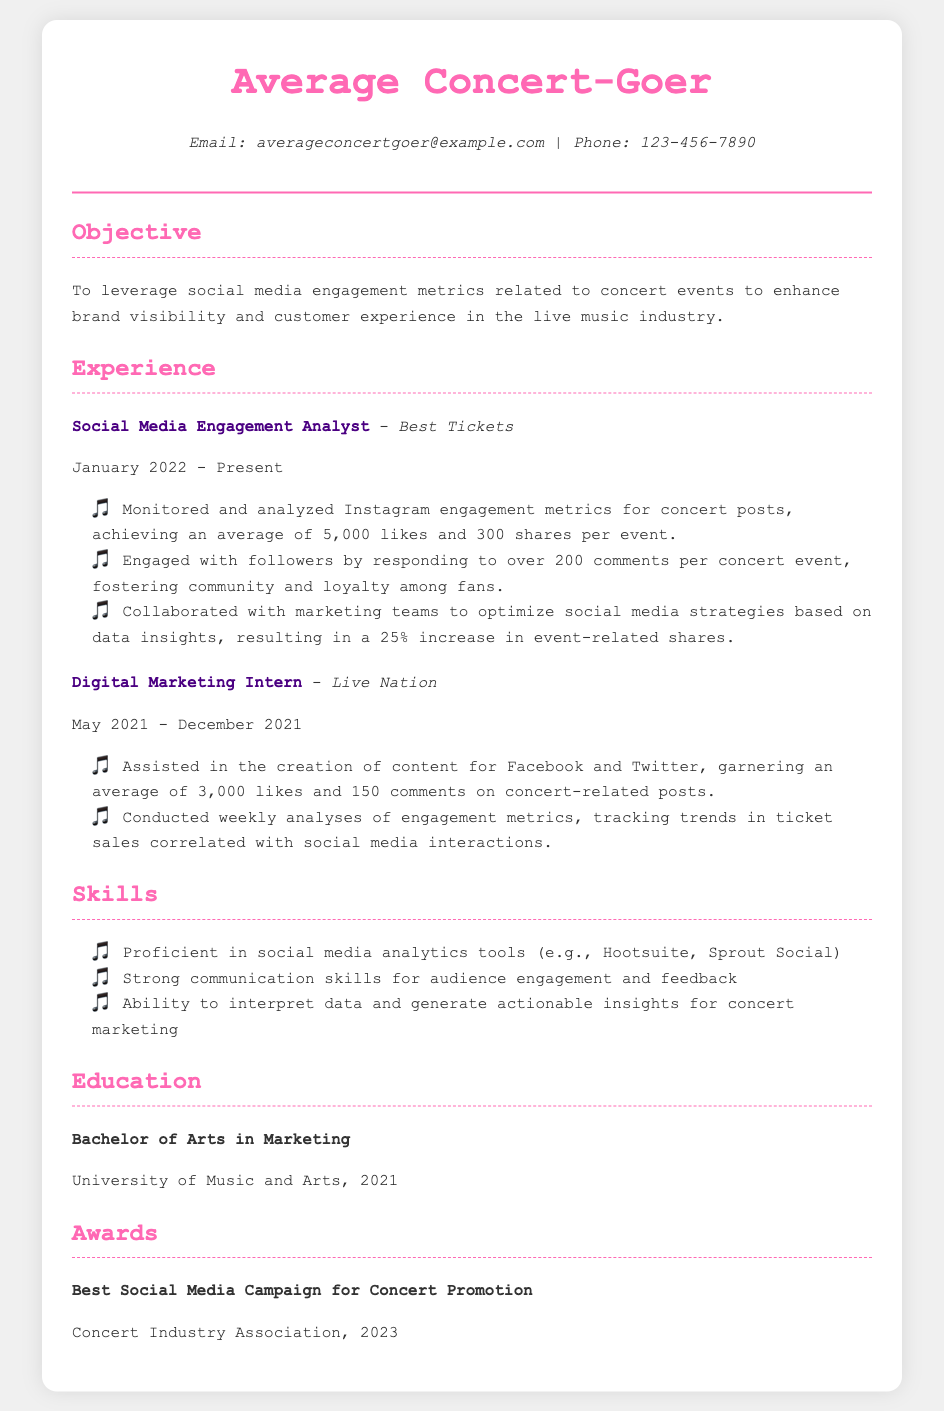what is the name of the current employer? The document specifies that the current employer is Best Tickets, where the individual is working as a Social Media Engagement Analyst.
Answer: Best Tickets how many likes does the average concert post receive? The average number of likes per event is mentioned in the document as 5,000 likes.
Answer: 5,000 what was the role of the individual at Live Nation? The title of the position held at Live Nation is mentioned, which is Digital Marketing Intern.
Answer: Digital Marketing Intern how many comments did the individual respond to per concert event? The document states that the individual responded to over 200 comments per concert event, indicating their level of engagement.
Answer: 200 what percentage increase in shares was achieved through social media strategies? The resume mentions a specific percentage increase in event-related shares, which is 25%.
Answer: 25% what is the highest award received by the individual? The highest award listed in the document is for the Best Social Media Campaign for Concert Promotion.
Answer: Best Social Media Campaign for Concert Promotion what is the degree obtained by the individual? The document indicates that the individual has a Bachelor of Arts in Marketing.
Answer: Bachelor of Arts in Marketing in which year did the individual graduate? The document specifies the graduation year as 2021.
Answer: 2021 